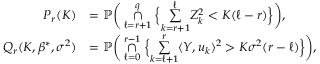Convert formula to latex. <formula><loc_0><loc_0><loc_500><loc_500>\begin{array} { r l } { P _ { r } ( K ) } & { = \mathbb { P } \left ( \underset { \ell = r + 1 } { \overset { q } { \cap } } \left \{ \underset { k = r + 1 } { \overset { \ell } { \sum } } Z _ { k } ^ { 2 } < K ( \ell - r ) \right \} \right ) , } \\ { Q _ { r } ( K , \beta ^ { * } , \sigma ^ { 2 } ) } & { = \mathbb { P } \left ( \underset { \ell = 0 } { \overset { r - 1 } { \cap } } \left \{ \underset { k = \ell + 1 } { \overset { r } { \sum } } \langle Y , u _ { k } \rangle ^ { 2 } > K \sigma ^ { 2 } ( r - \ell ) \right \} \right ) , } \end{array}</formula> 